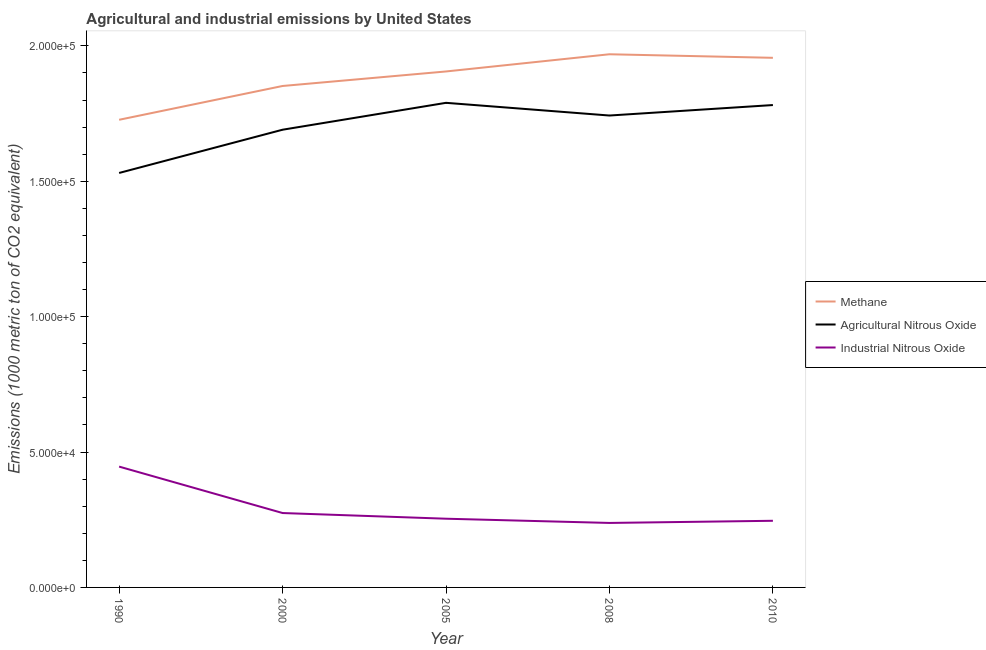Is the number of lines equal to the number of legend labels?
Your answer should be compact. Yes. What is the amount of agricultural nitrous oxide emissions in 2010?
Provide a succinct answer. 1.78e+05. Across all years, what is the maximum amount of methane emissions?
Your response must be concise. 1.97e+05. Across all years, what is the minimum amount of industrial nitrous oxide emissions?
Keep it short and to the point. 2.38e+04. In which year was the amount of agricultural nitrous oxide emissions maximum?
Provide a succinct answer. 2005. What is the total amount of agricultural nitrous oxide emissions in the graph?
Provide a succinct answer. 8.54e+05. What is the difference between the amount of agricultural nitrous oxide emissions in 2000 and that in 2008?
Give a very brief answer. -5242.4. What is the difference between the amount of industrial nitrous oxide emissions in 2008 and the amount of methane emissions in 2005?
Your answer should be very brief. -1.67e+05. What is the average amount of agricultural nitrous oxide emissions per year?
Your response must be concise. 1.71e+05. In the year 1990, what is the difference between the amount of industrial nitrous oxide emissions and amount of methane emissions?
Provide a short and direct response. -1.28e+05. What is the ratio of the amount of industrial nitrous oxide emissions in 2005 to that in 2010?
Your answer should be very brief. 1.03. Is the amount of methane emissions in 1990 less than that in 2000?
Your answer should be very brief. Yes. What is the difference between the highest and the second highest amount of industrial nitrous oxide emissions?
Make the answer very short. 1.71e+04. What is the difference between the highest and the lowest amount of methane emissions?
Provide a succinct answer. 2.42e+04. In how many years, is the amount of agricultural nitrous oxide emissions greater than the average amount of agricultural nitrous oxide emissions taken over all years?
Your answer should be very brief. 3. Is it the case that in every year, the sum of the amount of methane emissions and amount of agricultural nitrous oxide emissions is greater than the amount of industrial nitrous oxide emissions?
Make the answer very short. Yes. Is the amount of industrial nitrous oxide emissions strictly less than the amount of agricultural nitrous oxide emissions over the years?
Keep it short and to the point. Yes. How many lines are there?
Ensure brevity in your answer.  3. How many legend labels are there?
Make the answer very short. 3. How are the legend labels stacked?
Offer a terse response. Vertical. What is the title of the graph?
Offer a terse response. Agricultural and industrial emissions by United States. What is the label or title of the X-axis?
Make the answer very short. Year. What is the label or title of the Y-axis?
Provide a succinct answer. Emissions (1000 metric ton of CO2 equivalent). What is the Emissions (1000 metric ton of CO2 equivalent) of Methane in 1990?
Your answer should be very brief. 1.73e+05. What is the Emissions (1000 metric ton of CO2 equivalent) in Agricultural Nitrous Oxide in 1990?
Offer a very short reply. 1.53e+05. What is the Emissions (1000 metric ton of CO2 equivalent) in Industrial Nitrous Oxide in 1990?
Your answer should be very brief. 4.46e+04. What is the Emissions (1000 metric ton of CO2 equivalent) of Methane in 2000?
Your response must be concise. 1.85e+05. What is the Emissions (1000 metric ton of CO2 equivalent) in Agricultural Nitrous Oxide in 2000?
Make the answer very short. 1.69e+05. What is the Emissions (1000 metric ton of CO2 equivalent) of Industrial Nitrous Oxide in 2000?
Provide a succinct answer. 2.75e+04. What is the Emissions (1000 metric ton of CO2 equivalent) of Methane in 2005?
Keep it short and to the point. 1.91e+05. What is the Emissions (1000 metric ton of CO2 equivalent) of Agricultural Nitrous Oxide in 2005?
Your answer should be very brief. 1.79e+05. What is the Emissions (1000 metric ton of CO2 equivalent) of Industrial Nitrous Oxide in 2005?
Your response must be concise. 2.54e+04. What is the Emissions (1000 metric ton of CO2 equivalent) of Methane in 2008?
Give a very brief answer. 1.97e+05. What is the Emissions (1000 metric ton of CO2 equivalent) of Agricultural Nitrous Oxide in 2008?
Give a very brief answer. 1.74e+05. What is the Emissions (1000 metric ton of CO2 equivalent) of Industrial Nitrous Oxide in 2008?
Offer a terse response. 2.38e+04. What is the Emissions (1000 metric ton of CO2 equivalent) in Methane in 2010?
Offer a terse response. 1.96e+05. What is the Emissions (1000 metric ton of CO2 equivalent) in Agricultural Nitrous Oxide in 2010?
Your response must be concise. 1.78e+05. What is the Emissions (1000 metric ton of CO2 equivalent) of Industrial Nitrous Oxide in 2010?
Offer a very short reply. 2.46e+04. Across all years, what is the maximum Emissions (1000 metric ton of CO2 equivalent) in Methane?
Provide a succinct answer. 1.97e+05. Across all years, what is the maximum Emissions (1000 metric ton of CO2 equivalent) in Agricultural Nitrous Oxide?
Keep it short and to the point. 1.79e+05. Across all years, what is the maximum Emissions (1000 metric ton of CO2 equivalent) in Industrial Nitrous Oxide?
Offer a very short reply. 4.46e+04. Across all years, what is the minimum Emissions (1000 metric ton of CO2 equivalent) in Methane?
Your response must be concise. 1.73e+05. Across all years, what is the minimum Emissions (1000 metric ton of CO2 equivalent) of Agricultural Nitrous Oxide?
Your answer should be compact. 1.53e+05. Across all years, what is the minimum Emissions (1000 metric ton of CO2 equivalent) in Industrial Nitrous Oxide?
Offer a very short reply. 2.38e+04. What is the total Emissions (1000 metric ton of CO2 equivalent) in Methane in the graph?
Keep it short and to the point. 9.41e+05. What is the total Emissions (1000 metric ton of CO2 equivalent) in Agricultural Nitrous Oxide in the graph?
Ensure brevity in your answer.  8.54e+05. What is the total Emissions (1000 metric ton of CO2 equivalent) of Industrial Nitrous Oxide in the graph?
Offer a terse response. 1.46e+05. What is the difference between the Emissions (1000 metric ton of CO2 equivalent) of Methane in 1990 and that in 2000?
Give a very brief answer. -1.25e+04. What is the difference between the Emissions (1000 metric ton of CO2 equivalent) of Agricultural Nitrous Oxide in 1990 and that in 2000?
Your answer should be very brief. -1.60e+04. What is the difference between the Emissions (1000 metric ton of CO2 equivalent) in Industrial Nitrous Oxide in 1990 and that in 2000?
Offer a terse response. 1.71e+04. What is the difference between the Emissions (1000 metric ton of CO2 equivalent) in Methane in 1990 and that in 2005?
Your response must be concise. -1.78e+04. What is the difference between the Emissions (1000 metric ton of CO2 equivalent) in Agricultural Nitrous Oxide in 1990 and that in 2005?
Your answer should be very brief. -2.59e+04. What is the difference between the Emissions (1000 metric ton of CO2 equivalent) of Industrial Nitrous Oxide in 1990 and that in 2005?
Make the answer very short. 1.92e+04. What is the difference between the Emissions (1000 metric ton of CO2 equivalent) in Methane in 1990 and that in 2008?
Your answer should be very brief. -2.42e+04. What is the difference between the Emissions (1000 metric ton of CO2 equivalent) in Agricultural Nitrous Oxide in 1990 and that in 2008?
Make the answer very short. -2.12e+04. What is the difference between the Emissions (1000 metric ton of CO2 equivalent) of Industrial Nitrous Oxide in 1990 and that in 2008?
Offer a terse response. 2.08e+04. What is the difference between the Emissions (1000 metric ton of CO2 equivalent) of Methane in 1990 and that in 2010?
Offer a very short reply. -2.29e+04. What is the difference between the Emissions (1000 metric ton of CO2 equivalent) in Agricultural Nitrous Oxide in 1990 and that in 2010?
Provide a succinct answer. -2.51e+04. What is the difference between the Emissions (1000 metric ton of CO2 equivalent) of Industrial Nitrous Oxide in 1990 and that in 2010?
Give a very brief answer. 2.00e+04. What is the difference between the Emissions (1000 metric ton of CO2 equivalent) of Methane in 2000 and that in 2005?
Keep it short and to the point. -5362.7. What is the difference between the Emissions (1000 metric ton of CO2 equivalent) in Agricultural Nitrous Oxide in 2000 and that in 2005?
Give a very brief answer. -9931.2. What is the difference between the Emissions (1000 metric ton of CO2 equivalent) in Industrial Nitrous Oxide in 2000 and that in 2005?
Your answer should be very brief. 2099.2. What is the difference between the Emissions (1000 metric ton of CO2 equivalent) of Methane in 2000 and that in 2008?
Make the answer very short. -1.17e+04. What is the difference between the Emissions (1000 metric ton of CO2 equivalent) of Agricultural Nitrous Oxide in 2000 and that in 2008?
Offer a terse response. -5242.4. What is the difference between the Emissions (1000 metric ton of CO2 equivalent) of Industrial Nitrous Oxide in 2000 and that in 2008?
Keep it short and to the point. 3660.1. What is the difference between the Emissions (1000 metric ton of CO2 equivalent) of Methane in 2000 and that in 2010?
Offer a terse response. -1.04e+04. What is the difference between the Emissions (1000 metric ton of CO2 equivalent) in Agricultural Nitrous Oxide in 2000 and that in 2010?
Keep it short and to the point. -9113.5. What is the difference between the Emissions (1000 metric ton of CO2 equivalent) in Industrial Nitrous Oxide in 2000 and that in 2010?
Give a very brief answer. 2866.4. What is the difference between the Emissions (1000 metric ton of CO2 equivalent) of Methane in 2005 and that in 2008?
Your answer should be very brief. -6353.6. What is the difference between the Emissions (1000 metric ton of CO2 equivalent) in Agricultural Nitrous Oxide in 2005 and that in 2008?
Your response must be concise. 4688.8. What is the difference between the Emissions (1000 metric ton of CO2 equivalent) of Industrial Nitrous Oxide in 2005 and that in 2008?
Your answer should be very brief. 1560.9. What is the difference between the Emissions (1000 metric ton of CO2 equivalent) in Methane in 2005 and that in 2010?
Your response must be concise. -5038.6. What is the difference between the Emissions (1000 metric ton of CO2 equivalent) in Agricultural Nitrous Oxide in 2005 and that in 2010?
Offer a very short reply. 817.7. What is the difference between the Emissions (1000 metric ton of CO2 equivalent) of Industrial Nitrous Oxide in 2005 and that in 2010?
Your response must be concise. 767.2. What is the difference between the Emissions (1000 metric ton of CO2 equivalent) in Methane in 2008 and that in 2010?
Your answer should be very brief. 1315. What is the difference between the Emissions (1000 metric ton of CO2 equivalent) of Agricultural Nitrous Oxide in 2008 and that in 2010?
Provide a short and direct response. -3871.1. What is the difference between the Emissions (1000 metric ton of CO2 equivalent) of Industrial Nitrous Oxide in 2008 and that in 2010?
Offer a terse response. -793.7. What is the difference between the Emissions (1000 metric ton of CO2 equivalent) in Methane in 1990 and the Emissions (1000 metric ton of CO2 equivalent) in Agricultural Nitrous Oxide in 2000?
Ensure brevity in your answer.  3669.9. What is the difference between the Emissions (1000 metric ton of CO2 equivalent) of Methane in 1990 and the Emissions (1000 metric ton of CO2 equivalent) of Industrial Nitrous Oxide in 2000?
Provide a short and direct response. 1.45e+05. What is the difference between the Emissions (1000 metric ton of CO2 equivalent) of Agricultural Nitrous Oxide in 1990 and the Emissions (1000 metric ton of CO2 equivalent) of Industrial Nitrous Oxide in 2000?
Keep it short and to the point. 1.26e+05. What is the difference between the Emissions (1000 metric ton of CO2 equivalent) of Methane in 1990 and the Emissions (1000 metric ton of CO2 equivalent) of Agricultural Nitrous Oxide in 2005?
Offer a very short reply. -6261.3. What is the difference between the Emissions (1000 metric ton of CO2 equivalent) in Methane in 1990 and the Emissions (1000 metric ton of CO2 equivalent) in Industrial Nitrous Oxide in 2005?
Give a very brief answer. 1.47e+05. What is the difference between the Emissions (1000 metric ton of CO2 equivalent) in Agricultural Nitrous Oxide in 1990 and the Emissions (1000 metric ton of CO2 equivalent) in Industrial Nitrous Oxide in 2005?
Provide a short and direct response. 1.28e+05. What is the difference between the Emissions (1000 metric ton of CO2 equivalent) of Methane in 1990 and the Emissions (1000 metric ton of CO2 equivalent) of Agricultural Nitrous Oxide in 2008?
Ensure brevity in your answer.  -1572.5. What is the difference between the Emissions (1000 metric ton of CO2 equivalent) of Methane in 1990 and the Emissions (1000 metric ton of CO2 equivalent) of Industrial Nitrous Oxide in 2008?
Ensure brevity in your answer.  1.49e+05. What is the difference between the Emissions (1000 metric ton of CO2 equivalent) in Agricultural Nitrous Oxide in 1990 and the Emissions (1000 metric ton of CO2 equivalent) in Industrial Nitrous Oxide in 2008?
Offer a very short reply. 1.29e+05. What is the difference between the Emissions (1000 metric ton of CO2 equivalent) of Methane in 1990 and the Emissions (1000 metric ton of CO2 equivalent) of Agricultural Nitrous Oxide in 2010?
Provide a succinct answer. -5443.6. What is the difference between the Emissions (1000 metric ton of CO2 equivalent) in Methane in 1990 and the Emissions (1000 metric ton of CO2 equivalent) in Industrial Nitrous Oxide in 2010?
Make the answer very short. 1.48e+05. What is the difference between the Emissions (1000 metric ton of CO2 equivalent) of Agricultural Nitrous Oxide in 1990 and the Emissions (1000 metric ton of CO2 equivalent) of Industrial Nitrous Oxide in 2010?
Your response must be concise. 1.28e+05. What is the difference between the Emissions (1000 metric ton of CO2 equivalent) in Methane in 2000 and the Emissions (1000 metric ton of CO2 equivalent) in Agricultural Nitrous Oxide in 2005?
Your response must be concise. 6222.5. What is the difference between the Emissions (1000 metric ton of CO2 equivalent) of Methane in 2000 and the Emissions (1000 metric ton of CO2 equivalent) of Industrial Nitrous Oxide in 2005?
Offer a very short reply. 1.60e+05. What is the difference between the Emissions (1000 metric ton of CO2 equivalent) of Agricultural Nitrous Oxide in 2000 and the Emissions (1000 metric ton of CO2 equivalent) of Industrial Nitrous Oxide in 2005?
Your response must be concise. 1.44e+05. What is the difference between the Emissions (1000 metric ton of CO2 equivalent) in Methane in 2000 and the Emissions (1000 metric ton of CO2 equivalent) in Agricultural Nitrous Oxide in 2008?
Provide a succinct answer. 1.09e+04. What is the difference between the Emissions (1000 metric ton of CO2 equivalent) in Methane in 2000 and the Emissions (1000 metric ton of CO2 equivalent) in Industrial Nitrous Oxide in 2008?
Offer a very short reply. 1.61e+05. What is the difference between the Emissions (1000 metric ton of CO2 equivalent) in Agricultural Nitrous Oxide in 2000 and the Emissions (1000 metric ton of CO2 equivalent) in Industrial Nitrous Oxide in 2008?
Keep it short and to the point. 1.45e+05. What is the difference between the Emissions (1000 metric ton of CO2 equivalent) in Methane in 2000 and the Emissions (1000 metric ton of CO2 equivalent) in Agricultural Nitrous Oxide in 2010?
Ensure brevity in your answer.  7040.2. What is the difference between the Emissions (1000 metric ton of CO2 equivalent) of Methane in 2000 and the Emissions (1000 metric ton of CO2 equivalent) of Industrial Nitrous Oxide in 2010?
Offer a very short reply. 1.61e+05. What is the difference between the Emissions (1000 metric ton of CO2 equivalent) of Agricultural Nitrous Oxide in 2000 and the Emissions (1000 metric ton of CO2 equivalent) of Industrial Nitrous Oxide in 2010?
Offer a terse response. 1.44e+05. What is the difference between the Emissions (1000 metric ton of CO2 equivalent) of Methane in 2005 and the Emissions (1000 metric ton of CO2 equivalent) of Agricultural Nitrous Oxide in 2008?
Offer a very short reply. 1.63e+04. What is the difference between the Emissions (1000 metric ton of CO2 equivalent) in Methane in 2005 and the Emissions (1000 metric ton of CO2 equivalent) in Industrial Nitrous Oxide in 2008?
Keep it short and to the point. 1.67e+05. What is the difference between the Emissions (1000 metric ton of CO2 equivalent) of Agricultural Nitrous Oxide in 2005 and the Emissions (1000 metric ton of CO2 equivalent) of Industrial Nitrous Oxide in 2008?
Keep it short and to the point. 1.55e+05. What is the difference between the Emissions (1000 metric ton of CO2 equivalent) in Methane in 2005 and the Emissions (1000 metric ton of CO2 equivalent) in Agricultural Nitrous Oxide in 2010?
Your response must be concise. 1.24e+04. What is the difference between the Emissions (1000 metric ton of CO2 equivalent) in Methane in 2005 and the Emissions (1000 metric ton of CO2 equivalent) in Industrial Nitrous Oxide in 2010?
Ensure brevity in your answer.  1.66e+05. What is the difference between the Emissions (1000 metric ton of CO2 equivalent) in Agricultural Nitrous Oxide in 2005 and the Emissions (1000 metric ton of CO2 equivalent) in Industrial Nitrous Oxide in 2010?
Provide a short and direct response. 1.54e+05. What is the difference between the Emissions (1000 metric ton of CO2 equivalent) of Methane in 2008 and the Emissions (1000 metric ton of CO2 equivalent) of Agricultural Nitrous Oxide in 2010?
Your answer should be compact. 1.88e+04. What is the difference between the Emissions (1000 metric ton of CO2 equivalent) of Methane in 2008 and the Emissions (1000 metric ton of CO2 equivalent) of Industrial Nitrous Oxide in 2010?
Offer a very short reply. 1.72e+05. What is the difference between the Emissions (1000 metric ton of CO2 equivalent) in Agricultural Nitrous Oxide in 2008 and the Emissions (1000 metric ton of CO2 equivalent) in Industrial Nitrous Oxide in 2010?
Provide a succinct answer. 1.50e+05. What is the average Emissions (1000 metric ton of CO2 equivalent) of Methane per year?
Your answer should be compact. 1.88e+05. What is the average Emissions (1000 metric ton of CO2 equivalent) of Agricultural Nitrous Oxide per year?
Offer a terse response. 1.71e+05. What is the average Emissions (1000 metric ton of CO2 equivalent) of Industrial Nitrous Oxide per year?
Keep it short and to the point. 2.92e+04. In the year 1990, what is the difference between the Emissions (1000 metric ton of CO2 equivalent) of Methane and Emissions (1000 metric ton of CO2 equivalent) of Agricultural Nitrous Oxide?
Your answer should be compact. 1.96e+04. In the year 1990, what is the difference between the Emissions (1000 metric ton of CO2 equivalent) in Methane and Emissions (1000 metric ton of CO2 equivalent) in Industrial Nitrous Oxide?
Provide a succinct answer. 1.28e+05. In the year 1990, what is the difference between the Emissions (1000 metric ton of CO2 equivalent) of Agricultural Nitrous Oxide and Emissions (1000 metric ton of CO2 equivalent) of Industrial Nitrous Oxide?
Keep it short and to the point. 1.08e+05. In the year 2000, what is the difference between the Emissions (1000 metric ton of CO2 equivalent) of Methane and Emissions (1000 metric ton of CO2 equivalent) of Agricultural Nitrous Oxide?
Offer a terse response. 1.62e+04. In the year 2000, what is the difference between the Emissions (1000 metric ton of CO2 equivalent) of Methane and Emissions (1000 metric ton of CO2 equivalent) of Industrial Nitrous Oxide?
Offer a very short reply. 1.58e+05. In the year 2000, what is the difference between the Emissions (1000 metric ton of CO2 equivalent) in Agricultural Nitrous Oxide and Emissions (1000 metric ton of CO2 equivalent) in Industrial Nitrous Oxide?
Provide a short and direct response. 1.42e+05. In the year 2005, what is the difference between the Emissions (1000 metric ton of CO2 equivalent) of Methane and Emissions (1000 metric ton of CO2 equivalent) of Agricultural Nitrous Oxide?
Keep it short and to the point. 1.16e+04. In the year 2005, what is the difference between the Emissions (1000 metric ton of CO2 equivalent) in Methane and Emissions (1000 metric ton of CO2 equivalent) in Industrial Nitrous Oxide?
Keep it short and to the point. 1.65e+05. In the year 2005, what is the difference between the Emissions (1000 metric ton of CO2 equivalent) in Agricultural Nitrous Oxide and Emissions (1000 metric ton of CO2 equivalent) in Industrial Nitrous Oxide?
Your response must be concise. 1.54e+05. In the year 2008, what is the difference between the Emissions (1000 metric ton of CO2 equivalent) of Methane and Emissions (1000 metric ton of CO2 equivalent) of Agricultural Nitrous Oxide?
Your answer should be compact. 2.26e+04. In the year 2008, what is the difference between the Emissions (1000 metric ton of CO2 equivalent) of Methane and Emissions (1000 metric ton of CO2 equivalent) of Industrial Nitrous Oxide?
Keep it short and to the point. 1.73e+05. In the year 2008, what is the difference between the Emissions (1000 metric ton of CO2 equivalent) of Agricultural Nitrous Oxide and Emissions (1000 metric ton of CO2 equivalent) of Industrial Nitrous Oxide?
Provide a short and direct response. 1.50e+05. In the year 2010, what is the difference between the Emissions (1000 metric ton of CO2 equivalent) of Methane and Emissions (1000 metric ton of CO2 equivalent) of Agricultural Nitrous Oxide?
Offer a very short reply. 1.74e+04. In the year 2010, what is the difference between the Emissions (1000 metric ton of CO2 equivalent) in Methane and Emissions (1000 metric ton of CO2 equivalent) in Industrial Nitrous Oxide?
Give a very brief answer. 1.71e+05. In the year 2010, what is the difference between the Emissions (1000 metric ton of CO2 equivalent) of Agricultural Nitrous Oxide and Emissions (1000 metric ton of CO2 equivalent) of Industrial Nitrous Oxide?
Your answer should be compact. 1.54e+05. What is the ratio of the Emissions (1000 metric ton of CO2 equivalent) in Methane in 1990 to that in 2000?
Your answer should be compact. 0.93. What is the ratio of the Emissions (1000 metric ton of CO2 equivalent) in Agricultural Nitrous Oxide in 1990 to that in 2000?
Provide a short and direct response. 0.91. What is the ratio of the Emissions (1000 metric ton of CO2 equivalent) in Industrial Nitrous Oxide in 1990 to that in 2000?
Provide a short and direct response. 1.62. What is the ratio of the Emissions (1000 metric ton of CO2 equivalent) of Methane in 1990 to that in 2005?
Your answer should be compact. 0.91. What is the ratio of the Emissions (1000 metric ton of CO2 equivalent) in Agricultural Nitrous Oxide in 1990 to that in 2005?
Your answer should be very brief. 0.86. What is the ratio of the Emissions (1000 metric ton of CO2 equivalent) of Industrial Nitrous Oxide in 1990 to that in 2005?
Keep it short and to the point. 1.76. What is the ratio of the Emissions (1000 metric ton of CO2 equivalent) of Methane in 1990 to that in 2008?
Keep it short and to the point. 0.88. What is the ratio of the Emissions (1000 metric ton of CO2 equivalent) of Agricultural Nitrous Oxide in 1990 to that in 2008?
Give a very brief answer. 0.88. What is the ratio of the Emissions (1000 metric ton of CO2 equivalent) in Industrial Nitrous Oxide in 1990 to that in 2008?
Your response must be concise. 1.87. What is the ratio of the Emissions (1000 metric ton of CO2 equivalent) of Methane in 1990 to that in 2010?
Your answer should be compact. 0.88. What is the ratio of the Emissions (1000 metric ton of CO2 equivalent) of Agricultural Nitrous Oxide in 1990 to that in 2010?
Ensure brevity in your answer.  0.86. What is the ratio of the Emissions (1000 metric ton of CO2 equivalent) in Industrial Nitrous Oxide in 1990 to that in 2010?
Provide a succinct answer. 1.81. What is the ratio of the Emissions (1000 metric ton of CO2 equivalent) of Methane in 2000 to that in 2005?
Give a very brief answer. 0.97. What is the ratio of the Emissions (1000 metric ton of CO2 equivalent) in Agricultural Nitrous Oxide in 2000 to that in 2005?
Your answer should be compact. 0.94. What is the ratio of the Emissions (1000 metric ton of CO2 equivalent) in Industrial Nitrous Oxide in 2000 to that in 2005?
Provide a short and direct response. 1.08. What is the ratio of the Emissions (1000 metric ton of CO2 equivalent) in Methane in 2000 to that in 2008?
Ensure brevity in your answer.  0.94. What is the ratio of the Emissions (1000 metric ton of CO2 equivalent) of Agricultural Nitrous Oxide in 2000 to that in 2008?
Ensure brevity in your answer.  0.97. What is the ratio of the Emissions (1000 metric ton of CO2 equivalent) in Industrial Nitrous Oxide in 2000 to that in 2008?
Provide a short and direct response. 1.15. What is the ratio of the Emissions (1000 metric ton of CO2 equivalent) of Methane in 2000 to that in 2010?
Your answer should be very brief. 0.95. What is the ratio of the Emissions (1000 metric ton of CO2 equivalent) in Agricultural Nitrous Oxide in 2000 to that in 2010?
Give a very brief answer. 0.95. What is the ratio of the Emissions (1000 metric ton of CO2 equivalent) in Industrial Nitrous Oxide in 2000 to that in 2010?
Keep it short and to the point. 1.12. What is the ratio of the Emissions (1000 metric ton of CO2 equivalent) of Agricultural Nitrous Oxide in 2005 to that in 2008?
Your answer should be compact. 1.03. What is the ratio of the Emissions (1000 metric ton of CO2 equivalent) of Industrial Nitrous Oxide in 2005 to that in 2008?
Offer a terse response. 1.07. What is the ratio of the Emissions (1000 metric ton of CO2 equivalent) in Methane in 2005 to that in 2010?
Offer a very short reply. 0.97. What is the ratio of the Emissions (1000 metric ton of CO2 equivalent) of Agricultural Nitrous Oxide in 2005 to that in 2010?
Your response must be concise. 1. What is the ratio of the Emissions (1000 metric ton of CO2 equivalent) of Industrial Nitrous Oxide in 2005 to that in 2010?
Your response must be concise. 1.03. What is the ratio of the Emissions (1000 metric ton of CO2 equivalent) of Agricultural Nitrous Oxide in 2008 to that in 2010?
Offer a terse response. 0.98. What is the ratio of the Emissions (1000 metric ton of CO2 equivalent) in Industrial Nitrous Oxide in 2008 to that in 2010?
Make the answer very short. 0.97. What is the difference between the highest and the second highest Emissions (1000 metric ton of CO2 equivalent) of Methane?
Make the answer very short. 1315. What is the difference between the highest and the second highest Emissions (1000 metric ton of CO2 equivalent) in Agricultural Nitrous Oxide?
Keep it short and to the point. 817.7. What is the difference between the highest and the second highest Emissions (1000 metric ton of CO2 equivalent) of Industrial Nitrous Oxide?
Offer a very short reply. 1.71e+04. What is the difference between the highest and the lowest Emissions (1000 metric ton of CO2 equivalent) of Methane?
Make the answer very short. 2.42e+04. What is the difference between the highest and the lowest Emissions (1000 metric ton of CO2 equivalent) of Agricultural Nitrous Oxide?
Provide a succinct answer. 2.59e+04. What is the difference between the highest and the lowest Emissions (1000 metric ton of CO2 equivalent) of Industrial Nitrous Oxide?
Offer a terse response. 2.08e+04. 